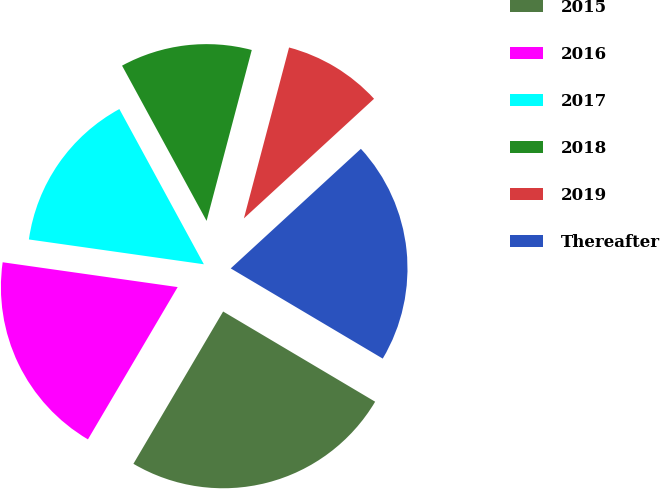Convert chart. <chart><loc_0><loc_0><loc_500><loc_500><pie_chart><fcel>2015<fcel>2016<fcel>2017<fcel>2018<fcel>2019<fcel>Thereafter<nl><fcel>24.95%<fcel>18.77%<fcel>14.82%<fcel>12.05%<fcel>9.06%<fcel>20.35%<nl></chart> 